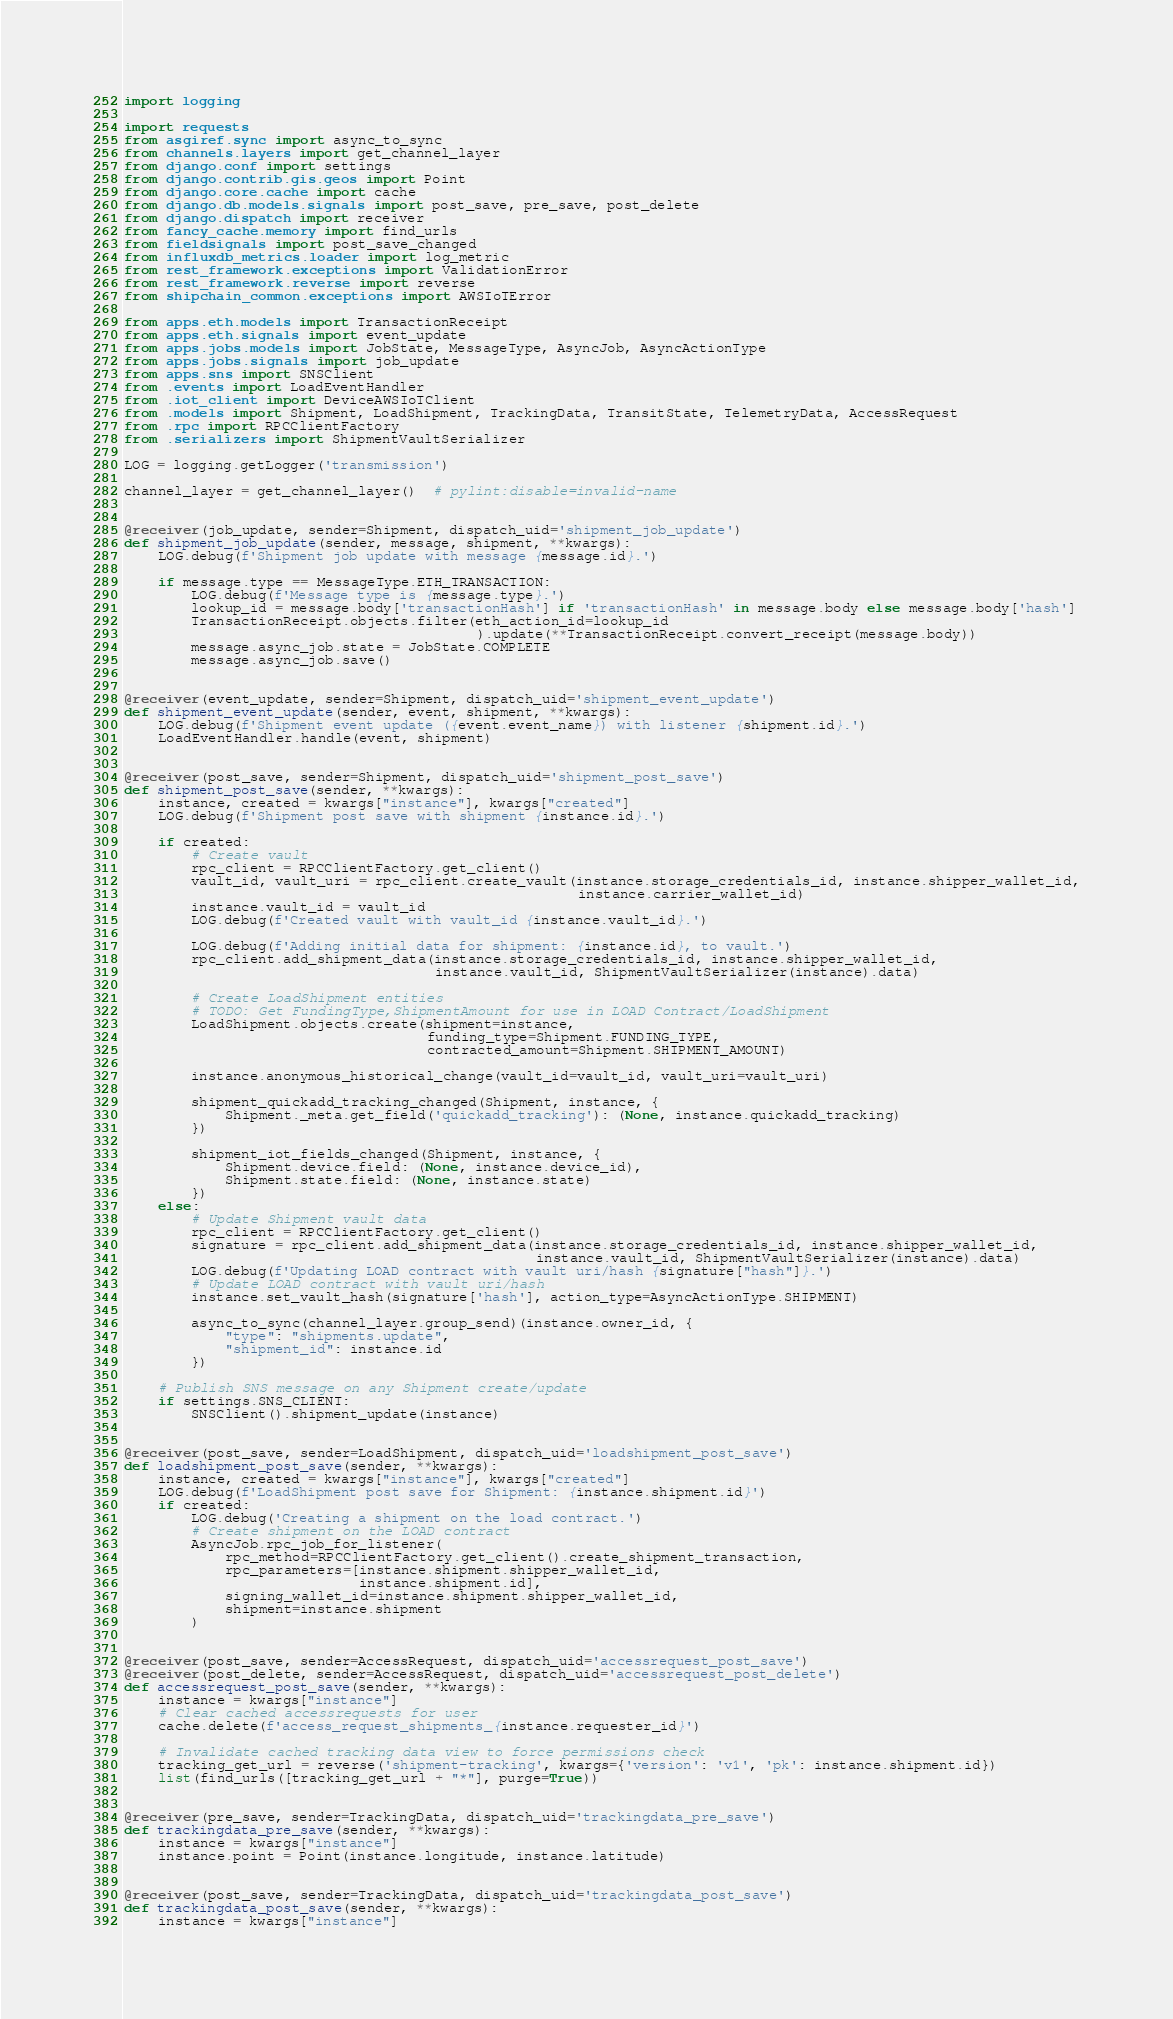<code> <loc_0><loc_0><loc_500><loc_500><_Python_>import logging

import requests
from asgiref.sync import async_to_sync
from channels.layers import get_channel_layer
from django.conf import settings
from django.contrib.gis.geos import Point
from django.core.cache import cache
from django.db.models.signals import post_save, pre_save, post_delete
from django.dispatch import receiver
from fancy_cache.memory import find_urls
from fieldsignals import post_save_changed
from influxdb_metrics.loader import log_metric
from rest_framework.exceptions import ValidationError
from rest_framework.reverse import reverse
from shipchain_common.exceptions import AWSIoTError

from apps.eth.models import TransactionReceipt
from apps.eth.signals import event_update
from apps.jobs.models import JobState, MessageType, AsyncJob, AsyncActionType
from apps.jobs.signals import job_update
from apps.sns import SNSClient
from .events import LoadEventHandler
from .iot_client import DeviceAWSIoTClient
from .models import Shipment, LoadShipment, TrackingData, TransitState, TelemetryData, AccessRequest
from .rpc import RPCClientFactory
from .serializers import ShipmentVaultSerializer

LOG = logging.getLogger('transmission')

channel_layer = get_channel_layer()  # pylint:disable=invalid-name


@receiver(job_update, sender=Shipment, dispatch_uid='shipment_job_update')
def shipment_job_update(sender, message, shipment, **kwargs):
    LOG.debug(f'Shipment job update with message {message.id}.')

    if message.type == MessageType.ETH_TRANSACTION:
        LOG.debug(f'Message type is {message.type}.')
        lookup_id = message.body['transactionHash'] if 'transactionHash' in message.body else message.body['hash']
        TransactionReceipt.objects.filter(eth_action_id=lookup_id
                                          ).update(**TransactionReceipt.convert_receipt(message.body))
        message.async_job.state = JobState.COMPLETE
        message.async_job.save()


@receiver(event_update, sender=Shipment, dispatch_uid='shipment_event_update')
def shipment_event_update(sender, event, shipment, **kwargs):
    LOG.debug(f'Shipment event update ({event.event_name}) with listener {shipment.id}.')
    LoadEventHandler.handle(event, shipment)


@receiver(post_save, sender=Shipment, dispatch_uid='shipment_post_save')
def shipment_post_save(sender, **kwargs):
    instance, created = kwargs["instance"], kwargs["created"]
    LOG.debug(f'Shipment post save with shipment {instance.id}.')

    if created:
        # Create vault
        rpc_client = RPCClientFactory.get_client()
        vault_id, vault_uri = rpc_client.create_vault(instance.storage_credentials_id, instance.shipper_wallet_id,
                                                      instance.carrier_wallet_id)
        instance.vault_id = vault_id
        LOG.debug(f'Created vault with vault_id {instance.vault_id}.')

        LOG.debug(f'Adding initial data for shipment: {instance.id}, to vault.')
        rpc_client.add_shipment_data(instance.storage_credentials_id, instance.shipper_wallet_id,
                                     instance.vault_id, ShipmentVaultSerializer(instance).data)

        # Create LoadShipment entities
        # TODO: Get FundingType,ShipmentAmount for use in LOAD Contract/LoadShipment
        LoadShipment.objects.create(shipment=instance,
                                    funding_type=Shipment.FUNDING_TYPE,
                                    contracted_amount=Shipment.SHIPMENT_AMOUNT)

        instance.anonymous_historical_change(vault_id=vault_id, vault_uri=vault_uri)

        shipment_quickadd_tracking_changed(Shipment, instance, {
            Shipment._meta.get_field('quickadd_tracking'): (None, instance.quickadd_tracking)
        })

        shipment_iot_fields_changed(Shipment, instance, {
            Shipment.device.field: (None, instance.device_id),
            Shipment.state.field: (None, instance.state)
        })
    else:
        # Update Shipment vault data
        rpc_client = RPCClientFactory.get_client()
        signature = rpc_client.add_shipment_data(instance.storage_credentials_id, instance.shipper_wallet_id,
                                                 instance.vault_id, ShipmentVaultSerializer(instance).data)
        LOG.debug(f'Updating LOAD contract with vault uri/hash {signature["hash"]}.')
        # Update LOAD contract with vault uri/hash
        instance.set_vault_hash(signature['hash'], action_type=AsyncActionType.SHIPMENT)

        async_to_sync(channel_layer.group_send)(instance.owner_id, {
            "type": "shipments.update",
            "shipment_id": instance.id
        })

    # Publish SNS message on any Shipment create/update
    if settings.SNS_CLIENT:
        SNSClient().shipment_update(instance)


@receiver(post_save, sender=LoadShipment, dispatch_uid='loadshipment_post_save')
def loadshipment_post_save(sender, **kwargs):
    instance, created = kwargs["instance"], kwargs["created"]
    LOG.debug(f'LoadShipment post save for Shipment: {instance.shipment.id}')
    if created:
        LOG.debug('Creating a shipment on the load contract.')
        # Create shipment on the LOAD contract
        AsyncJob.rpc_job_for_listener(
            rpc_method=RPCClientFactory.get_client().create_shipment_transaction,
            rpc_parameters=[instance.shipment.shipper_wallet_id,
                            instance.shipment.id],
            signing_wallet_id=instance.shipment.shipper_wallet_id,
            shipment=instance.shipment
        )


@receiver(post_save, sender=AccessRequest, dispatch_uid='accessrequest_post_save')
@receiver(post_delete, sender=AccessRequest, dispatch_uid='accessrequest_post_delete')
def accessrequest_post_save(sender, **kwargs):
    instance = kwargs["instance"]
    # Clear cached accessrequests for user
    cache.delete(f'access_request_shipments_{instance.requester_id}')

    # Invalidate cached tracking data view to force permissions check
    tracking_get_url = reverse('shipment-tracking', kwargs={'version': 'v1', 'pk': instance.shipment.id})
    list(find_urls([tracking_get_url + "*"], purge=True))


@receiver(pre_save, sender=TrackingData, dispatch_uid='trackingdata_pre_save')
def trackingdata_pre_save(sender, **kwargs):
    instance = kwargs["instance"]
    instance.point = Point(instance.longitude, instance.latitude)


@receiver(post_save, sender=TrackingData, dispatch_uid='trackingdata_post_save')
def trackingdata_post_save(sender, **kwargs):
    instance = kwargs["instance"]</code> 